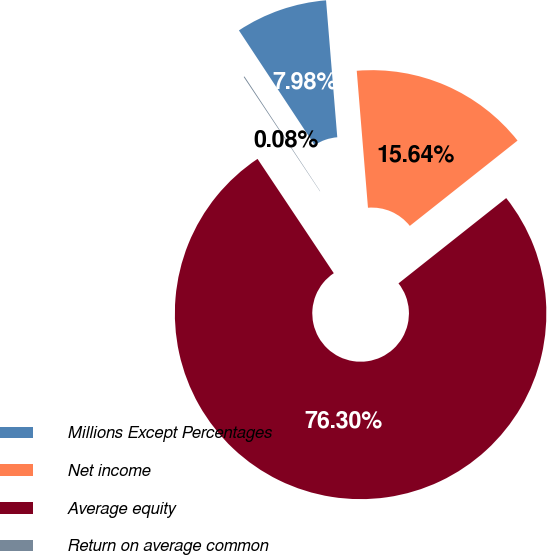Convert chart. <chart><loc_0><loc_0><loc_500><loc_500><pie_chart><fcel>Millions Except Percentages<fcel>Net income<fcel>Average equity<fcel>Return on average common<nl><fcel>7.98%<fcel>15.64%<fcel>76.29%<fcel>0.08%<nl></chart> 